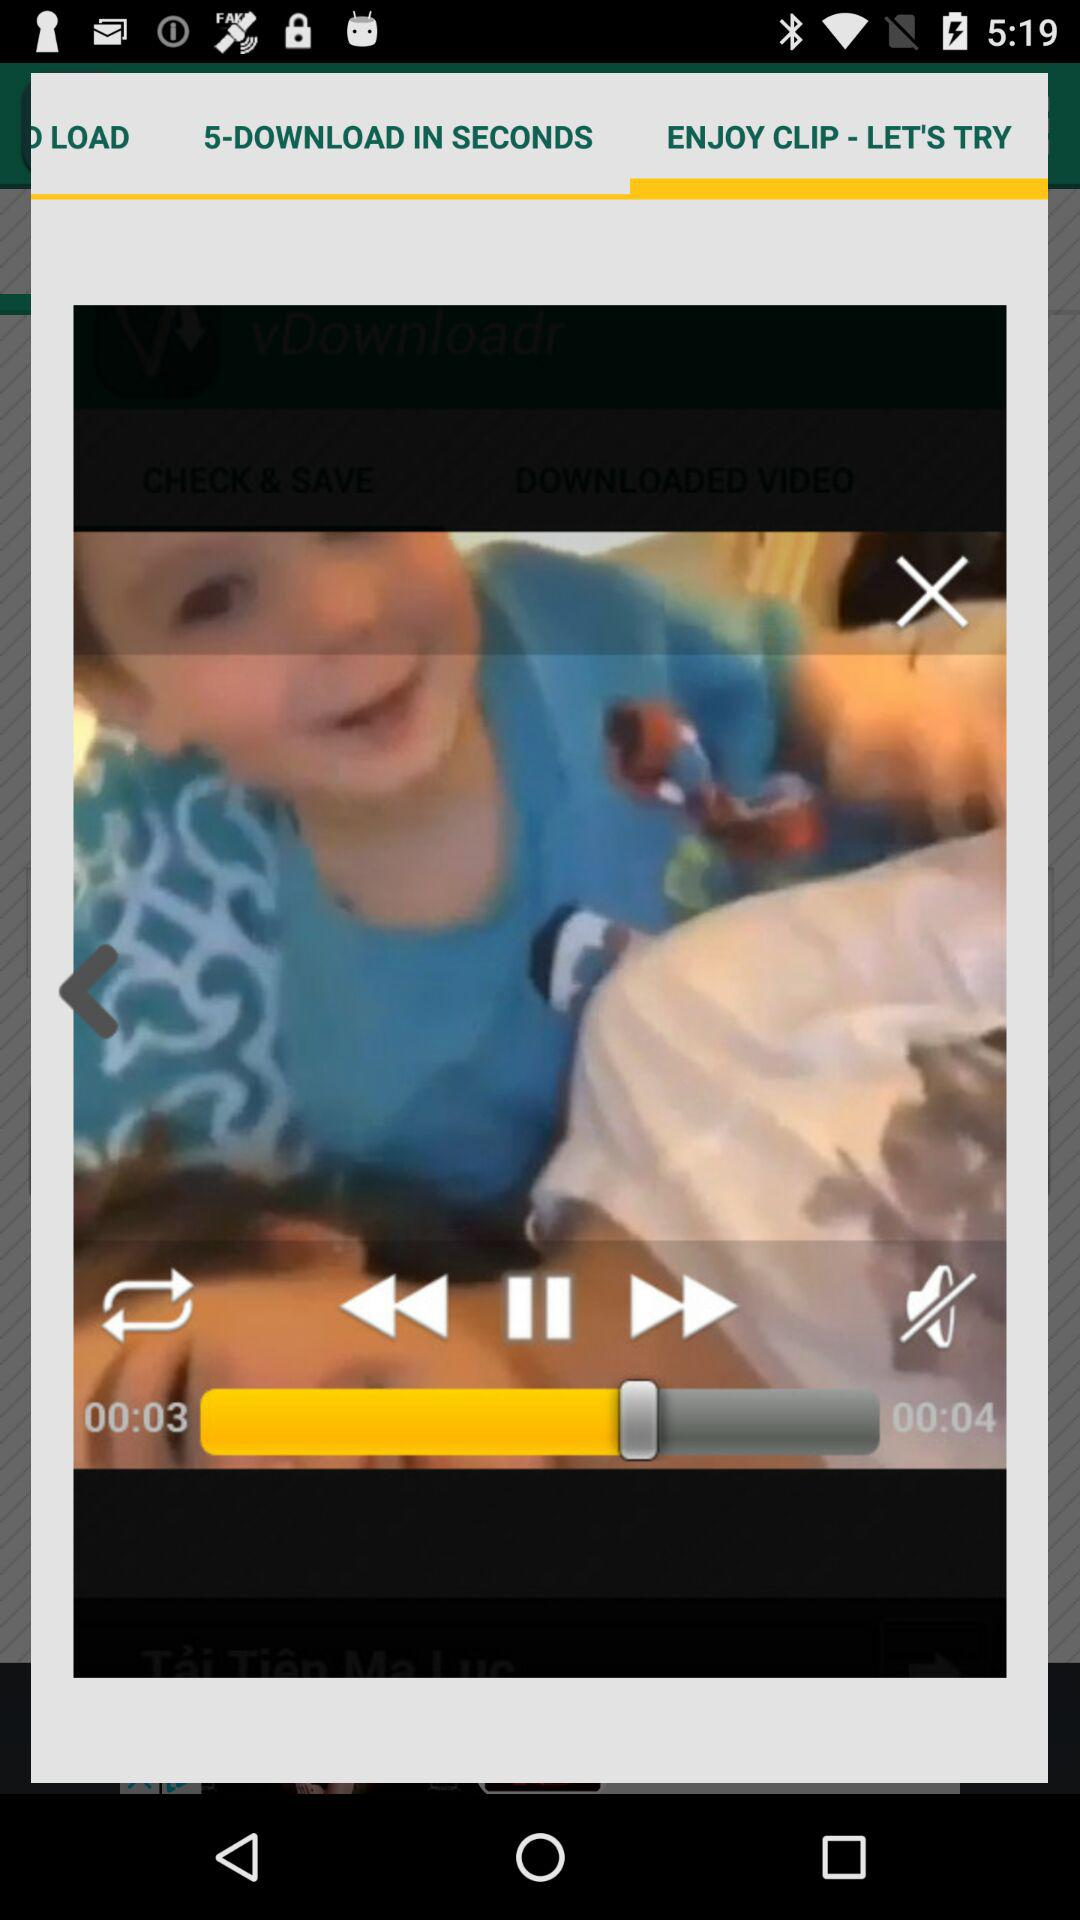Which tab is selected? The selected tab is "ENJOY CLIP - LET'S TRY". 